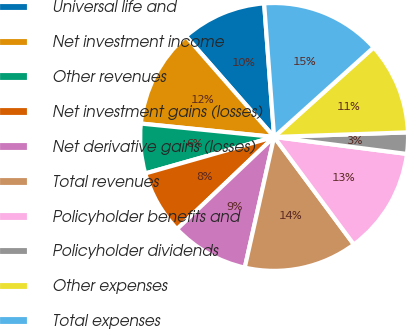Convert chart. <chart><loc_0><loc_0><loc_500><loc_500><pie_chart><fcel>Universal life and<fcel>Net investment income<fcel>Other revenues<fcel>Net investment gains (losses)<fcel>Net derivative gains (losses)<fcel>Total revenues<fcel>Policyholder benefits and<fcel>Policyholder dividends<fcel>Other expenses<fcel>Total expenses<nl><fcel>10.26%<fcel>11.96%<fcel>5.99%<fcel>7.69%<fcel>9.4%<fcel>13.67%<fcel>12.82%<fcel>2.57%<fcel>11.11%<fcel>14.53%<nl></chart> 